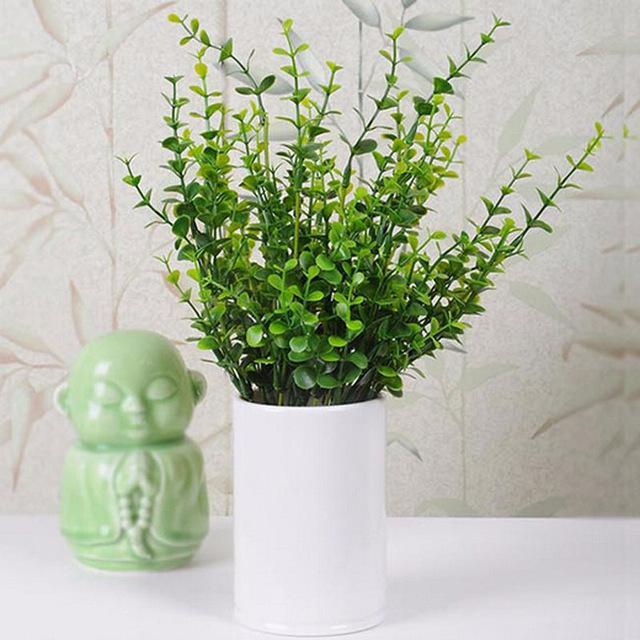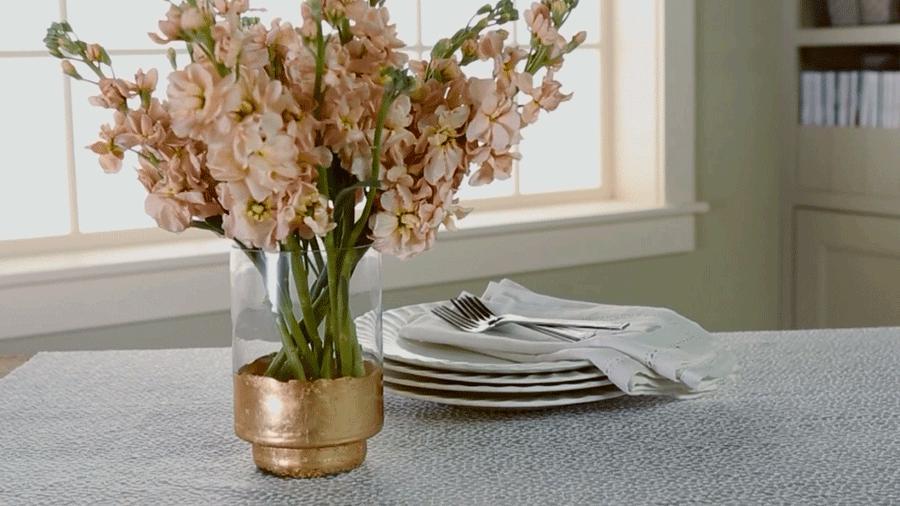The first image is the image on the left, the second image is the image on the right. For the images displayed, is the sentence "In at least one image there is a vase wit the bottle looking metallic." factually correct? Answer yes or no. Yes. The first image is the image on the left, the second image is the image on the right. Given the left and right images, does the statement "there is a vase of flowers sitting in front of a window" hold true? Answer yes or no. Yes. 